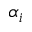Convert formula to latex. <formula><loc_0><loc_0><loc_500><loc_500>\alpha _ { i }</formula> 